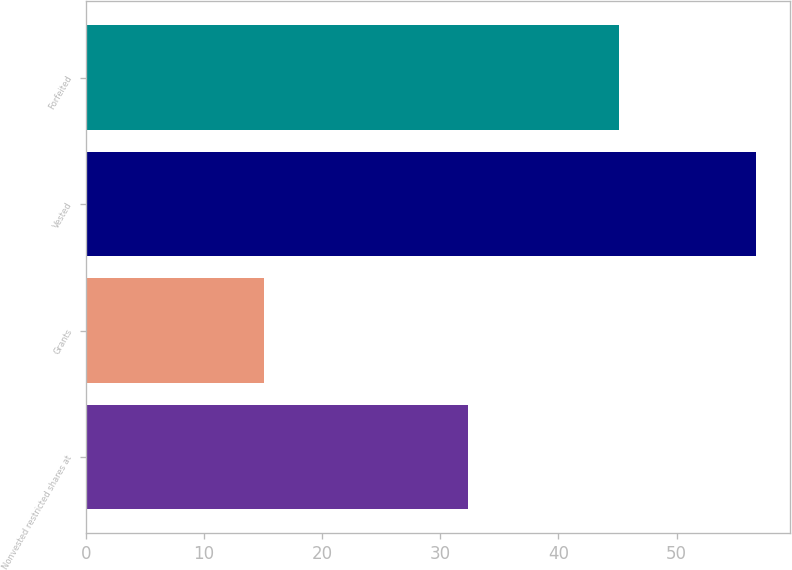Convert chart to OTSL. <chart><loc_0><loc_0><loc_500><loc_500><bar_chart><fcel>Nonvested restricted shares at<fcel>Grants<fcel>Vested<fcel>Forfeited<nl><fcel>32.33<fcel>15.11<fcel>56.72<fcel>45.16<nl></chart> 